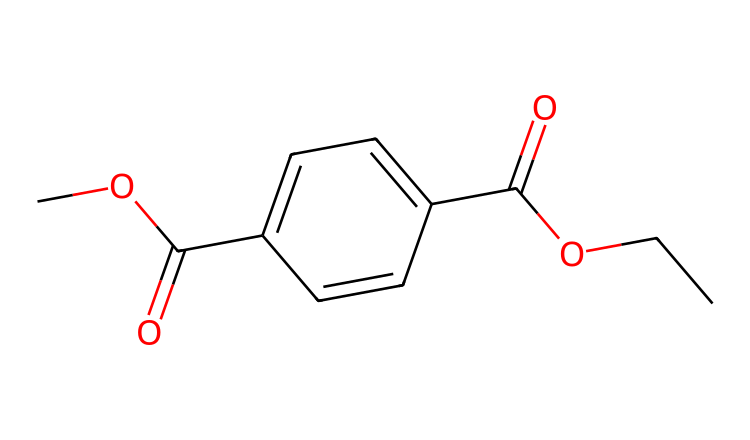What is the common name for this chemical? The chemical is known as polyethylene terephthalate, commonly abbreviated as PET. This name comes from its structure, which includes terephthalic acid and ethylene glycol components.
Answer: polyethylene terephthalate How many carbon atoms are present in this structure? By analyzing the SMILES representation, we can count the carbon atoms. There are 10 carbon atoms depicted in the structure.
Answer: 10 What type of bonds are primarily present in polyethylene terephthalate? The structure contains ester and carbon-carbon bonds (C-C). The presence of the ester functional groups indicates that this polymer consists of repeating units linked by ester bonds.
Answer: ester bonds What functional groups can be identified in the structure? The SMILES notation indicates the presence of ester (–COO–) and hydroxyl (–OH) functional groups. These are key to the polymer’s properties, particularly its thermal stability and water resistance.
Answer: ester and hydroxyl What is the main reason PET is used for making plastic bottles? PET is favored for bottle production due to its strength, lightweight nature, and excellent barrier properties. The polymer's structure, composed of both the aromatic and aliphatic components, confers these characteristics.
Answer: strength and barrier properties What is the degree of crystallinity typically found in PET? PET generally exhibits a semi-crystalline structure, with a typical crystallinity degree that can vary between 30% to 50%. This degree affects its physical properties such as clarity and barrier performance.
Answer: 30% to 50% What type of polymerization process is used to produce PET? PET is produced through a step-growth polymerization known as condensation polymerization. This process involves the reaction of monomers, leading to the formation of long polymer chains while releasing small molecules, such as water.
Answer: condensation polymerization 